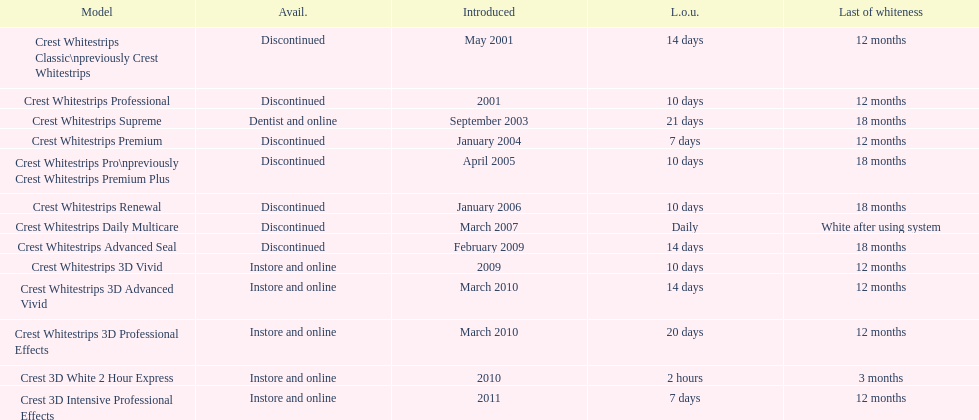I'm looking to parse the entire table for insights. Could you assist me with that? {'header': ['Model', 'Avail.', 'Introduced', 'L.o.u.', 'Last of whiteness'], 'rows': [['Crest Whitestrips Classic\\npreviously Crest Whitestrips', 'Discontinued', 'May 2001', '14 days', '12 months'], ['Crest Whitestrips Professional', 'Discontinued', '2001', '10 days', '12 months'], ['Crest Whitestrips Supreme', 'Dentist and online', 'September 2003', '21 days', '18 months'], ['Crest Whitestrips Premium', 'Discontinued', 'January 2004', '7 days', '12 months'], ['Crest Whitestrips Pro\\npreviously Crest Whitestrips Premium Plus', 'Discontinued', 'April 2005', '10 days', '18 months'], ['Crest Whitestrips Renewal', 'Discontinued', 'January 2006', '10 days', '18 months'], ['Crest Whitestrips Daily Multicare', 'Discontinued', 'March 2007', 'Daily', 'White after using system'], ['Crest Whitestrips Advanced Seal', 'Discontinued', 'February 2009', '14 days', '18 months'], ['Crest Whitestrips 3D Vivid', 'Instore and online', '2009', '10 days', '12 months'], ['Crest Whitestrips 3D Advanced Vivid', 'Instore and online', 'March 2010', '14 days', '12 months'], ['Crest Whitestrips 3D Professional Effects', 'Instore and online', 'March 2010', '20 days', '12 months'], ['Crest 3D White 2 Hour Express', 'Instore and online', '2010', '2 hours', '3 months'], ['Crest 3D Intensive Professional Effects', 'Instore and online', '2011', '7 days', '12 months']]} What is the number of products that were introduced in 2010? 3. 